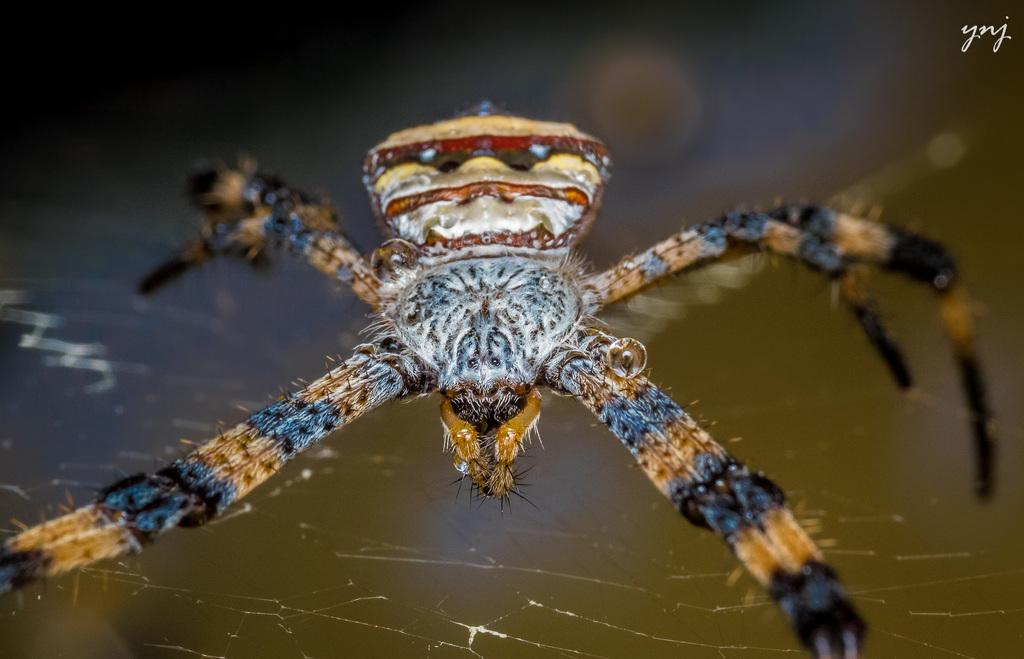What is the main subject in the foreground of the image? There is an insect in the foreground of the image. What can be observed about the background of the image? The background of the image is blurred. How many credits are visible on the insect in the image? There are no credits visible on the insect in the image, as credits are typically associated with movies or television shows and not insects. 